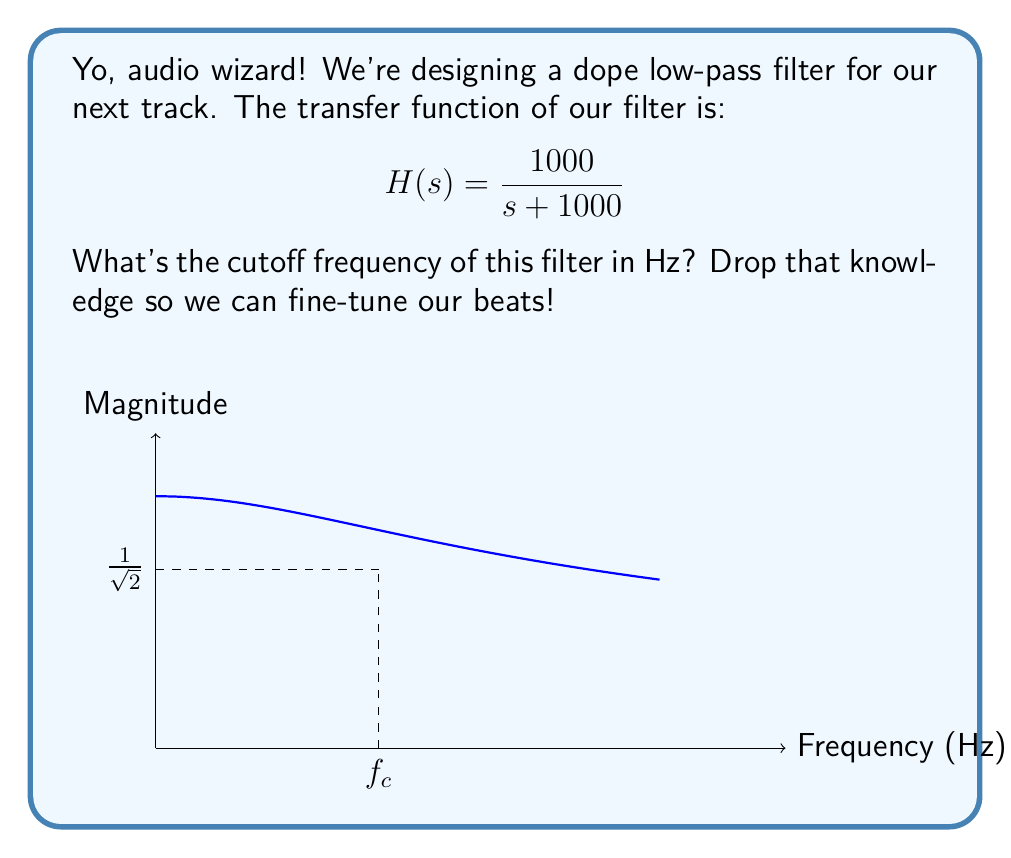What is the answer to this math problem? Alright, let's break this down step by step:

1) The transfer function $H(s)$ represents a first-order low-pass filter.

2) For a first-order low-pass filter, the cutoff frequency $\omega_c$ (in rad/s) occurs when the magnitude of $H(j\omega)$ is $\frac{1}{\sqrt{2}}$ of its maximum value.

3) Let's substitute $s$ with $j\omega$ in our transfer function:

   $$H(j\omega) = \frac{1000}{j\omega + 1000}$$

4) The magnitude of this complex function is:

   $$|H(j\omega)| = \frac{1000}{\sqrt{\omega^2 + 1000^2}}$$

5) At the cutoff frequency, this magnitude equals $\frac{1}{\sqrt{2}}$:

   $$\frac{1000}{\sqrt{\omega_c^2 + 1000^2}} = \frac{1}{\sqrt{2}}$$

6) Solving this equation:

   $$\omega_c^2 + 1000^2 = 2 \cdot 1000^2$$
   $$\omega_c^2 = 1000^2$$
   $$\omega_c = 1000 \text{ rad/s}$$

7) To convert from rad/s to Hz, we divide by $2\pi$:

   $$f_c = \frac{\omega_c}{2\pi} = \frac{1000}{2\pi} \approx 159.15 \text{ Hz}$$

8) Rounding to the nearest whole number:

   $$f_c \approx 159 \text{ Hz}$$
Answer: 159 Hz 